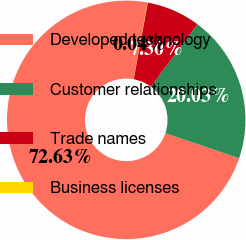<chart> <loc_0><loc_0><loc_500><loc_500><pie_chart><fcel>Developed technology<fcel>Customer relationships<fcel>Trade names<fcel>Business licenses<nl><fcel>72.62%<fcel>20.03%<fcel>7.3%<fcel>0.04%<nl></chart> 